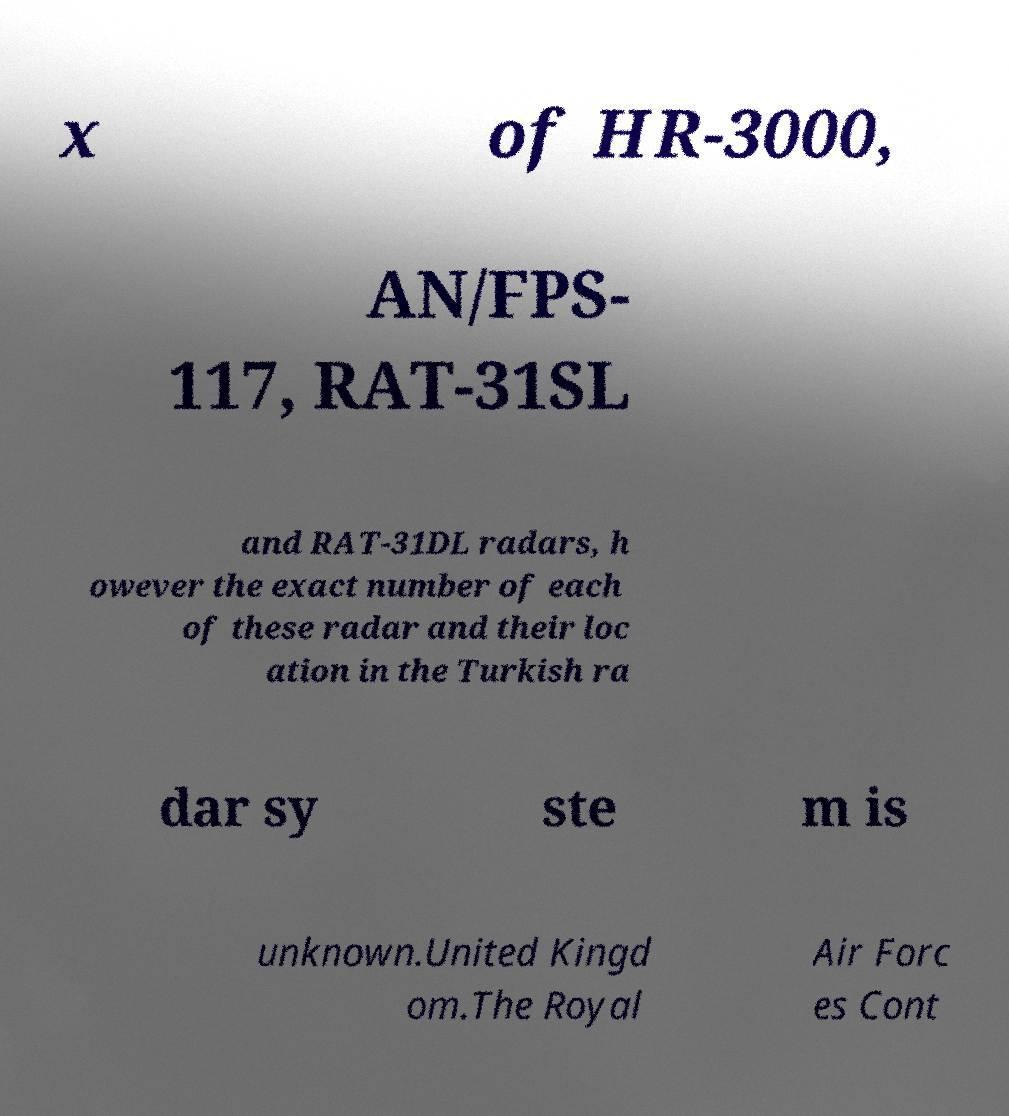There's text embedded in this image that I need extracted. Can you transcribe it verbatim? x of HR-3000, AN/FPS- 117, RAT-31SL and RAT-31DL radars, h owever the exact number of each of these radar and their loc ation in the Turkish ra dar sy ste m is unknown.United Kingd om.The Royal Air Forc es Cont 